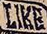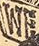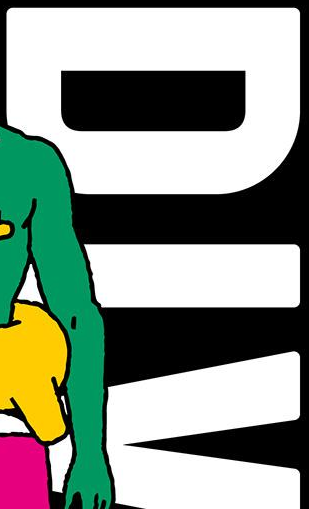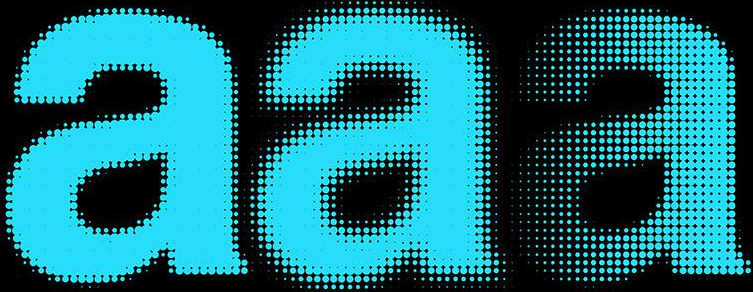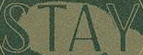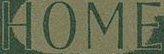What text is displayed in these images sequentially, separated by a semicolon? LIKE; WE; DIV; aaa; STAY; HOME 